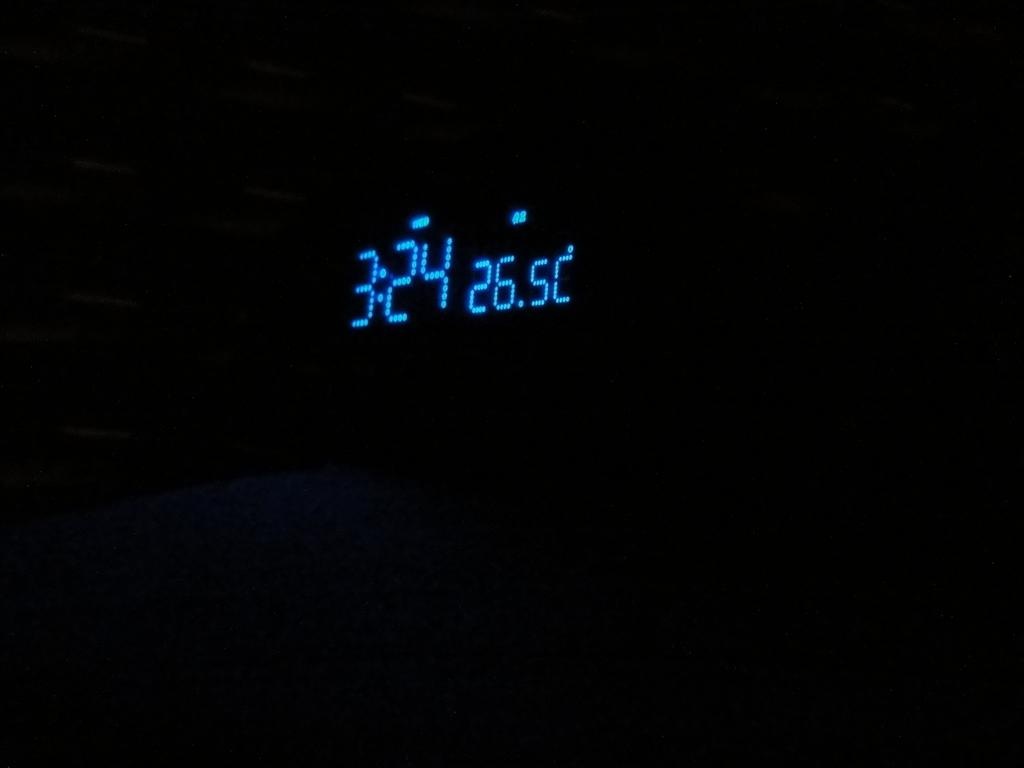Provide a one-sentence caption for the provided image. A digital clock shows blue numbers of 3:24. 